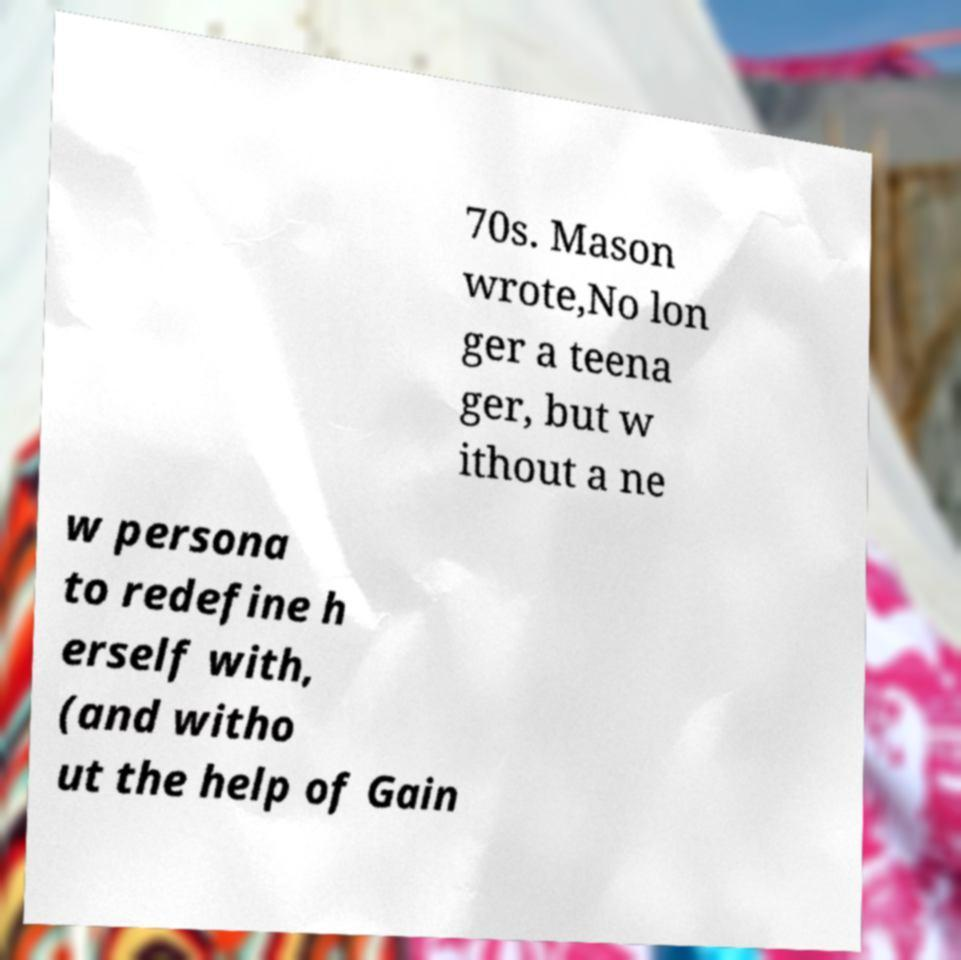I need the written content from this picture converted into text. Can you do that? 70s. Mason wrote,No lon ger a teena ger, but w ithout a ne w persona to redefine h erself with, (and witho ut the help of Gain 